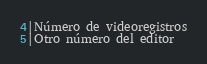Convert code to text. <code><loc_0><loc_0><loc_500><loc_500><_SQL_>4|Número de videoregistros
5|Otro número del editor</code> 